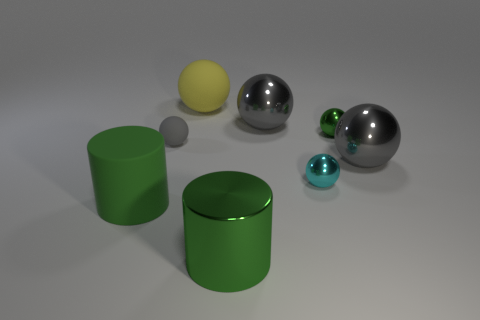Subtract all brown blocks. How many gray spheres are left? 3 Add 1 gray matte balls. How many objects exist? 9 Subtract 4 balls. How many balls are left? 2 Subtract all small rubber balls. How many balls are left? 5 Subtract all cyan spheres. How many spheres are left? 5 Subtract all spheres. How many objects are left? 2 Subtract 0 yellow blocks. How many objects are left? 8 Subtract all red spheres. Subtract all blue cylinders. How many spheres are left? 6 Subtract all small green metallic things. Subtract all green cylinders. How many objects are left? 5 Add 4 cyan balls. How many cyan balls are left? 5 